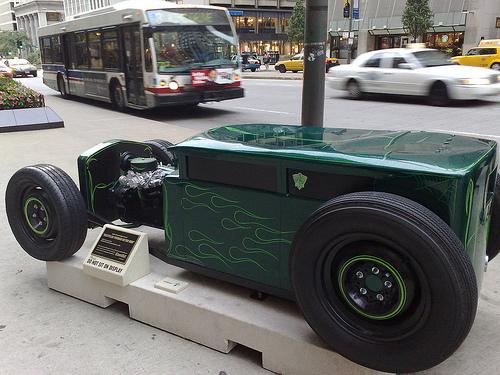In a few words, describe the atmosphere of the location in the image. The atmosphere is bustling with traffic and activity on a city street. Identify the primary object in the picture and describe its key features. The large green motorbox with tires is the main object, featuring a black rubber tire with a lime green rim and an engine in the car. Provide a brief description of the scene depicted in the image. The scene shows a busy city street filled with various vehicles including buses, taxi cabs, and a car on display, along with buildings and street elements. Describe one major element in the image and its position in relation to other elements. The large green motorbox with tires is positioned next to the busy street, surrounded by various vehicles including buses, taxi cabs, and a white car in motion. List five notable objects found in the image and their respective sizes. 5. Skinny tree planted on city sidewalk - Width:41 Height:41 